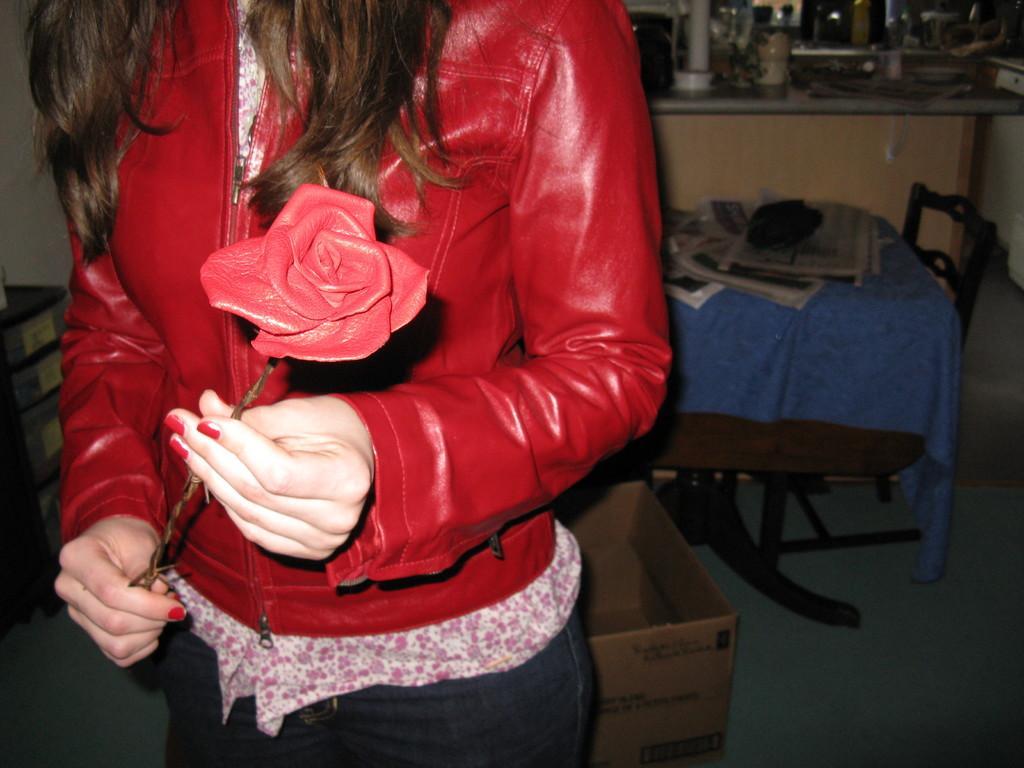How would you summarize this image in a sentence or two? The woman in red jacket is holding a flower. Far there is a table, on a table there are newspapers. Cardboard box in on floor. 